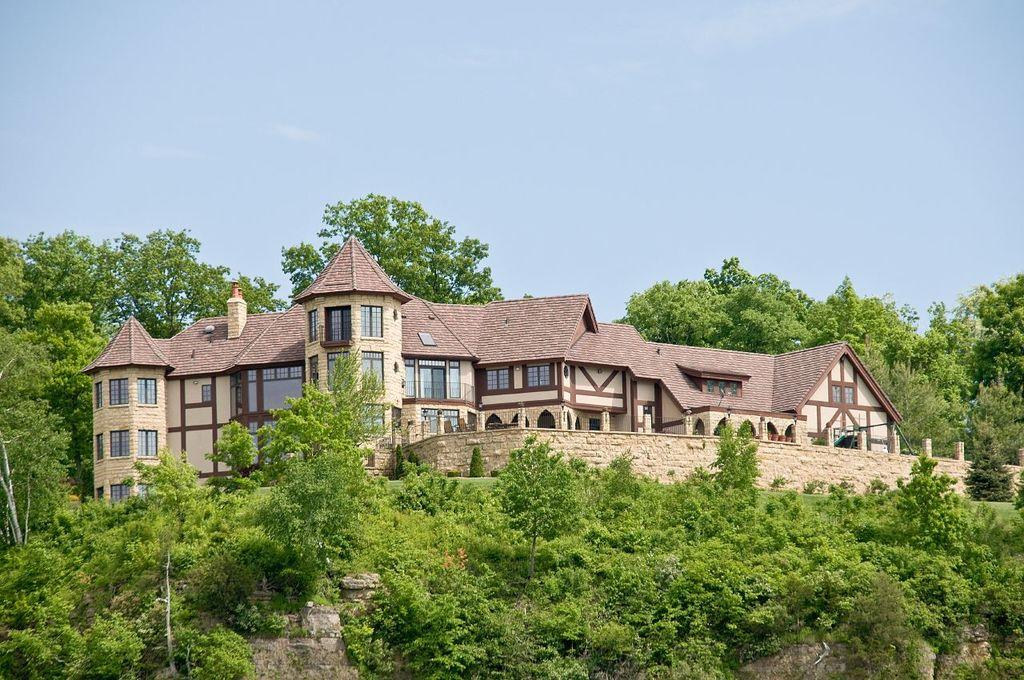What type of vegetation is present in the image? There are trees in the image. What type of structure can be seen in the image? There is a building with windows in the image. What can be seen in the background of the image? The sky is visible in the background of the image. What type of card is being used by the fowl in the image? There is no card or fowl present in the image. Is the image taken during the winter season? The provided facts do not mention the season or weather, so it cannot be determined from the image. 